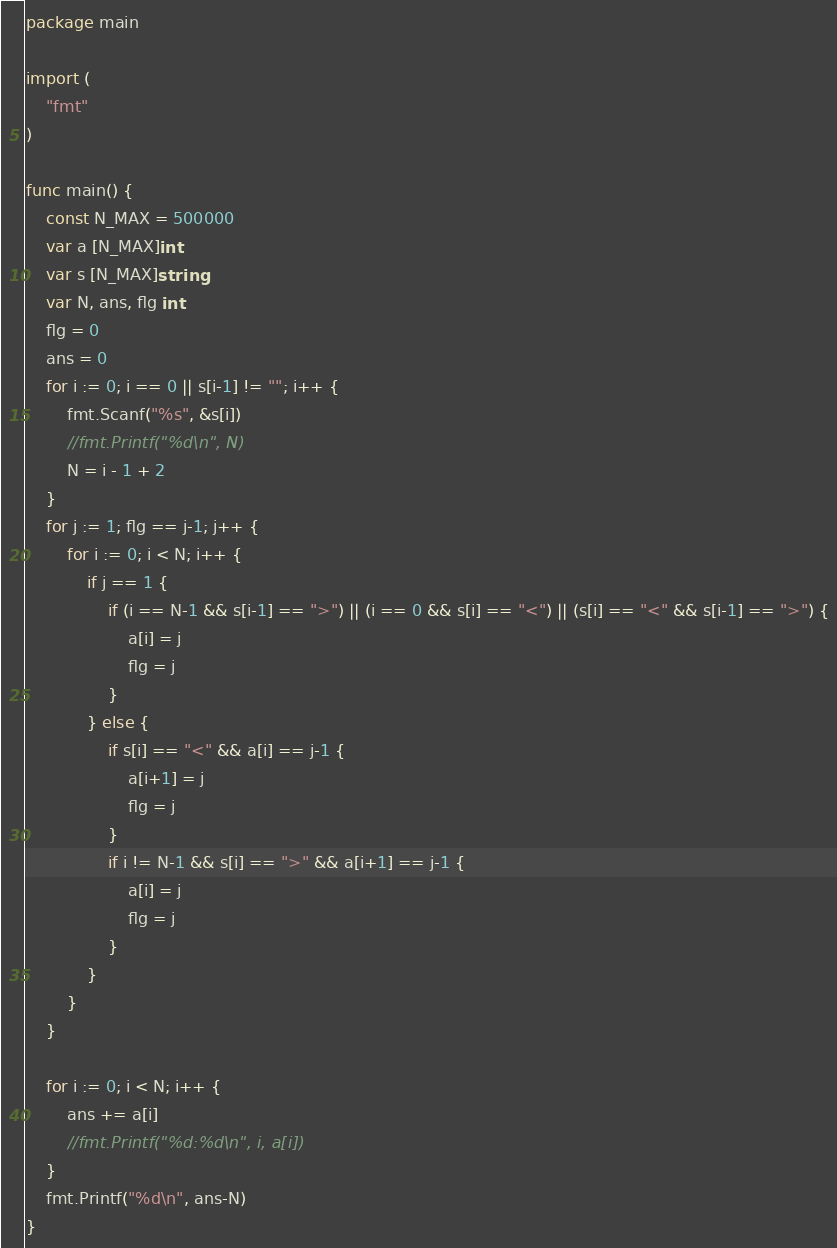Convert code to text. <code><loc_0><loc_0><loc_500><loc_500><_Go_>package main

import (
	"fmt"
)

func main() {
	const N_MAX = 500000
	var a [N_MAX]int
	var s [N_MAX]string
	var N, ans, flg int
	flg = 0
	ans = 0
	for i := 0; i == 0 || s[i-1] != ""; i++ {
		fmt.Scanf("%s", &s[i])
		//fmt.Printf("%d\n", N)
		N = i - 1 + 2
	}
	for j := 1; flg == j-1; j++ {
		for i := 0; i < N; i++ {
			if j == 1 {
				if (i == N-1 && s[i-1] == ">") || (i == 0 && s[i] == "<") || (s[i] == "<" && s[i-1] == ">") {
					a[i] = j
					flg = j
				}
			} else {
				if s[i] == "<" && a[i] == j-1 {
					a[i+1] = j
					flg = j
				}
				if i != N-1 && s[i] == ">" && a[i+1] == j-1 {
					a[i] = j
					flg = j
				}
			}
		}
	}

	for i := 0; i < N; i++ {
		ans += a[i]
		//fmt.Printf("%d:%d\n", i, a[i])
	}
	fmt.Printf("%d\n", ans-N)
}
</code> 